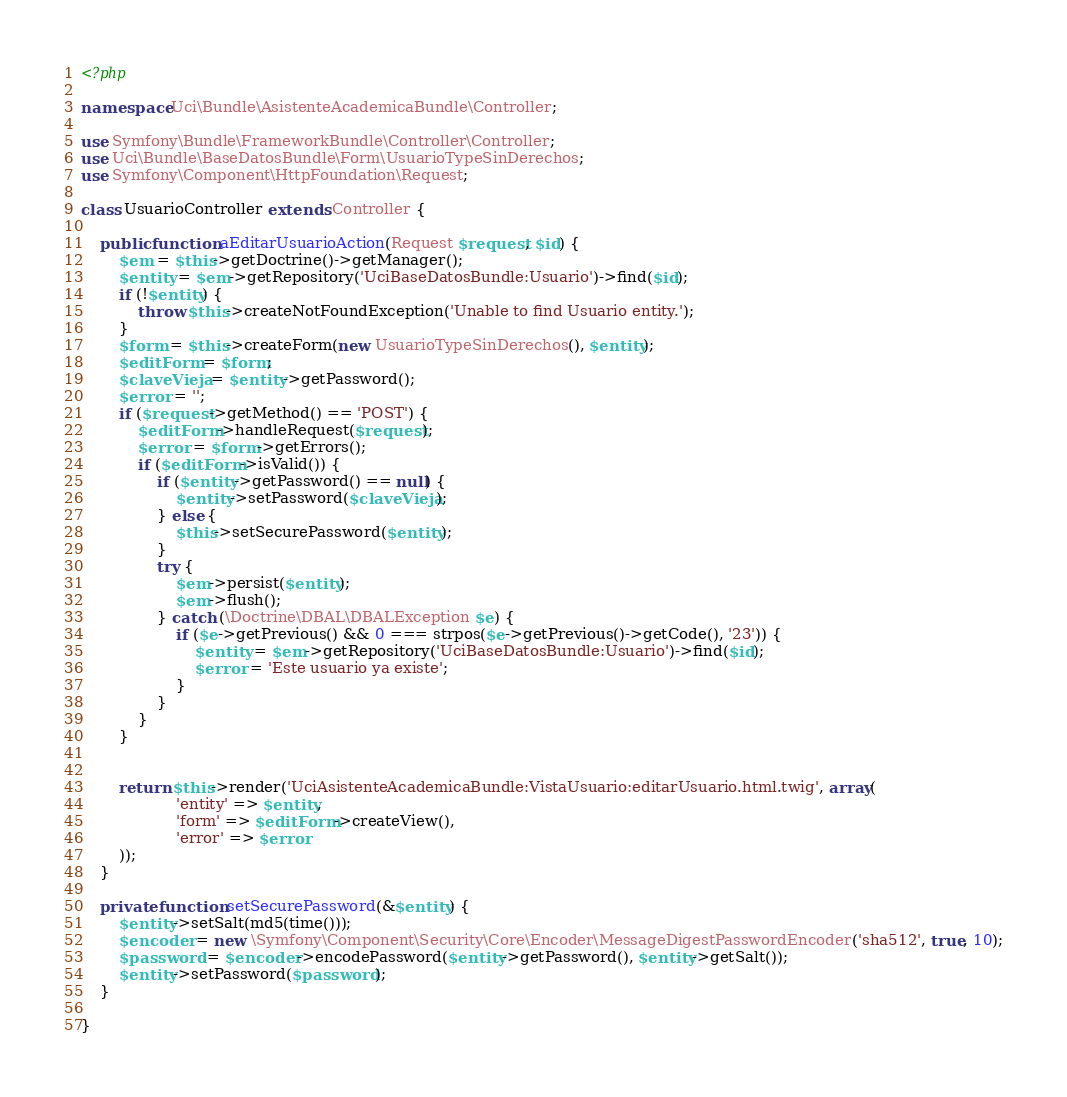<code> <loc_0><loc_0><loc_500><loc_500><_PHP_><?php

namespace Uci\Bundle\AsistenteAcademicaBundle\Controller;

use Symfony\Bundle\FrameworkBundle\Controller\Controller;
use Uci\Bundle\BaseDatosBundle\Form\UsuarioTypeSinDerechos;
use Symfony\Component\HttpFoundation\Request;

class UsuarioController extends Controller {

    public function aEditarUsuarioAction(Request $request, $id) {
        $em = $this->getDoctrine()->getManager();
        $entity = $em->getRepository('UciBaseDatosBundle:Usuario')->find($id);
        if (!$entity) {
            throw $this->createNotFoundException('Unable to find Usuario entity.');
        }
        $form = $this->createForm(new UsuarioTypeSinDerechos(), $entity);
        $editForm = $form;
        $claveVieja = $entity->getPassword();
        $error = '';
        if ($request->getMethod() == 'POST') {
            $editForm->handleRequest($request);
            $error = $form->getErrors();
            if ($editForm->isValid()) {
                if ($entity->getPassword() == null) {
                    $entity->setPassword($claveVieja);
                } else {
                    $this->setSecurePassword($entity);
                }
                try {
                    $em->persist($entity);
                    $em->flush();
                } catch (\Doctrine\DBAL\DBALException $e) {
                    if ($e->getPrevious() && 0 === strpos($e->getPrevious()->getCode(), '23')) {
                        $entity = $em->getRepository('UciBaseDatosBundle:Usuario')->find($id);
                        $error = 'Este usuario ya existe';
                    }
                }
            }
        }


        return $this->render('UciAsistenteAcademicaBundle:VistaUsuario:editarUsuario.html.twig', array(
                    'entity' => $entity,
                    'form' => $editForm->createView(),
                    'error' => $error
        ));
    }

    private function setSecurePassword(&$entity) {
        $entity->setSalt(md5(time()));
        $encoder = new \Symfony\Component\Security\Core\Encoder\MessageDigestPasswordEncoder('sha512', true, 10);
        $password = $encoder->encodePassword($entity->getPassword(), $entity->getSalt());
        $entity->setPassword($password);
    }

}
</code> 